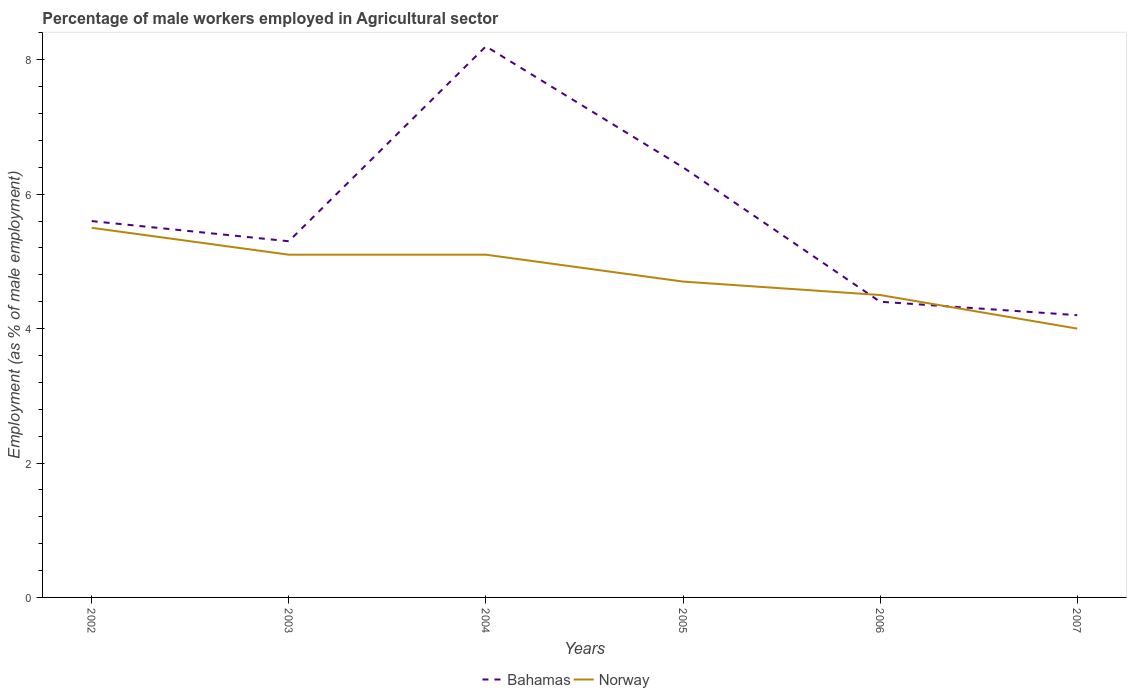How many different coloured lines are there?
Provide a succinct answer. 2. Is the number of lines equal to the number of legend labels?
Give a very brief answer. Yes. Across all years, what is the maximum percentage of male workers employed in Agricultural sector in Norway?
Offer a terse response. 4. What is the total percentage of male workers employed in Agricultural sector in Bahamas in the graph?
Give a very brief answer. -2.9. How many lines are there?
Offer a terse response. 2. How many legend labels are there?
Offer a terse response. 2. What is the title of the graph?
Give a very brief answer. Percentage of male workers employed in Agricultural sector. What is the label or title of the X-axis?
Offer a terse response. Years. What is the label or title of the Y-axis?
Your answer should be very brief. Employment (as % of male employment). What is the Employment (as % of male employment) of Bahamas in 2002?
Offer a very short reply. 5.6. What is the Employment (as % of male employment) of Norway in 2002?
Your answer should be compact. 5.5. What is the Employment (as % of male employment) in Bahamas in 2003?
Provide a succinct answer. 5.3. What is the Employment (as % of male employment) in Norway in 2003?
Keep it short and to the point. 5.1. What is the Employment (as % of male employment) in Bahamas in 2004?
Give a very brief answer. 8.2. What is the Employment (as % of male employment) in Norway in 2004?
Ensure brevity in your answer.  5.1. What is the Employment (as % of male employment) of Bahamas in 2005?
Keep it short and to the point. 6.4. What is the Employment (as % of male employment) of Norway in 2005?
Offer a very short reply. 4.7. What is the Employment (as % of male employment) of Bahamas in 2006?
Ensure brevity in your answer.  4.4. What is the Employment (as % of male employment) in Bahamas in 2007?
Your answer should be very brief. 4.2. What is the Employment (as % of male employment) of Norway in 2007?
Ensure brevity in your answer.  4. Across all years, what is the maximum Employment (as % of male employment) of Bahamas?
Give a very brief answer. 8.2. Across all years, what is the minimum Employment (as % of male employment) of Bahamas?
Your answer should be very brief. 4.2. Across all years, what is the minimum Employment (as % of male employment) of Norway?
Give a very brief answer. 4. What is the total Employment (as % of male employment) in Bahamas in the graph?
Your answer should be compact. 34.1. What is the total Employment (as % of male employment) in Norway in the graph?
Make the answer very short. 28.9. What is the difference between the Employment (as % of male employment) in Norway in 2002 and that in 2003?
Your answer should be compact. 0.4. What is the difference between the Employment (as % of male employment) of Bahamas in 2002 and that in 2005?
Provide a short and direct response. -0.8. What is the difference between the Employment (as % of male employment) of Norway in 2002 and that in 2006?
Your response must be concise. 1. What is the difference between the Employment (as % of male employment) of Bahamas in 2002 and that in 2007?
Make the answer very short. 1.4. What is the difference between the Employment (as % of male employment) in Norway in 2002 and that in 2007?
Provide a succinct answer. 1.5. What is the difference between the Employment (as % of male employment) in Bahamas in 2003 and that in 2004?
Offer a terse response. -2.9. What is the difference between the Employment (as % of male employment) of Norway in 2003 and that in 2004?
Your answer should be very brief. 0. What is the difference between the Employment (as % of male employment) of Norway in 2003 and that in 2006?
Provide a succinct answer. 0.6. What is the difference between the Employment (as % of male employment) in Bahamas in 2004 and that in 2006?
Keep it short and to the point. 3.8. What is the difference between the Employment (as % of male employment) in Norway in 2004 and that in 2006?
Provide a succinct answer. 0.6. What is the difference between the Employment (as % of male employment) in Bahamas in 2005 and that in 2006?
Keep it short and to the point. 2. What is the difference between the Employment (as % of male employment) in Bahamas in 2006 and that in 2007?
Provide a succinct answer. 0.2. What is the difference between the Employment (as % of male employment) in Norway in 2006 and that in 2007?
Keep it short and to the point. 0.5. What is the difference between the Employment (as % of male employment) in Bahamas in 2002 and the Employment (as % of male employment) in Norway in 2003?
Make the answer very short. 0.5. What is the difference between the Employment (as % of male employment) of Bahamas in 2002 and the Employment (as % of male employment) of Norway in 2004?
Keep it short and to the point. 0.5. What is the difference between the Employment (as % of male employment) of Bahamas in 2003 and the Employment (as % of male employment) of Norway in 2004?
Keep it short and to the point. 0.2. What is the average Employment (as % of male employment) of Bahamas per year?
Offer a very short reply. 5.68. What is the average Employment (as % of male employment) in Norway per year?
Keep it short and to the point. 4.82. In the year 2002, what is the difference between the Employment (as % of male employment) of Bahamas and Employment (as % of male employment) of Norway?
Give a very brief answer. 0.1. In the year 2007, what is the difference between the Employment (as % of male employment) of Bahamas and Employment (as % of male employment) of Norway?
Ensure brevity in your answer.  0.2. What is the ratio of the Employment (as % of male employment) in Bahamas in 2002 to that in 2003?
Offer a very short reply. 1.06. What is the ratio of the Employment (as % of male employment) of Norway in 2002 to that in 2003?
Give a very brief answer. 1.08. What is the ratio of the Employment (as % of male employment) in Bahamas in 2002 to that in 2004?
Your response must be concise. 0.68. What is the ratio of the Employment (as % of male employment) in Norway in 2002 to that in 2004?
Your response must be concise. 1.08. What is the ratio of the Employment (as % of male employment) in Norway in 2002 to that in 2005?
Give a very brief answer. 1.17. What is the ratio of the Employment (as % of male employment) in Bahamas in 2002 to that in 2006?
Provide a succinct answer. 1.27. What is the ratio of the Employment (as % of male employment) of Norway in 2002 to that in 2006?
Provide a succinct answer. 1.22. What is the ratio of the Employment (as % of male employment) in Norway in 2002 to that in 2007?
Make the answer very short. 1.38. What is the ratio of the Employment (as % of male employment) of Bahamas in 2003 to that in 2004?
Your response must be concise. 0.65. What is the ratio of the Employment (as % of male employment) in Bahamas in 2003 to that in 2005?
Your response must be concise. 0.83. What is the ratio of the Employment (as % of male employment) in Norway in 2003 to that in 2005?
Provide a succinct answer. 1.09. What is the ratio of the Employment (as % of male employment) in Bahamas in 2003 to that in 2006?
Keep it short and to the point. 1.2. What is the ratio of the Employment (as % of male employment) in Norway in 2003 to that in 2006?
Your response must be concise. 1.13. What is the ratio of the Employment (as % of male employment) in Bahamas in 2003 to that in 2007?
Your answer should be compact. 1.26. What is the ratio of the Employment (as % of male employment) in Norway in 2003 to that in 2007?
Make the answer very short. 1.27. What is the ratio of the Employment (as % of male employment) of Bahamas in 2004 to that in 2005?
Keep it short and to the point. 1.28. What is the ratio of the Employment (as % of male employment) of Norway in 2004 to that in 2005?
Offer a terse response. 1.09. What is the ratio of the Employment (as % of male employment) in Bahamas in 2004 to that in 2006?
Offer a terse response. 1.86. What is the ratio of the Employment (as % of male employment) of Norway in 2004 to that in 2006?
Give a very brief answer. 1.13. What is the ratio of the Employment (as % of male employment) in Bahamas in 2004 to that in 2007?
Your response must be concise. 1.95. What is the ratio of the Employment (as % of male employment) in Norway in 2004 to that in 2007?
Offer a very short reply. 1.27. What is the ratio of the Employment (as % of male employment) in Bahamas in 2005 to that in 2006?
Ensure brevity in your answer.  1.45. What is the ratio of the Employment (as % of male employment) of Norway in 2005 to that in 2006?
Your response must be concise. 1.04. What is the ratio of the Employment (as % of male employment) in Bahamas in 2005 to that in 2007?
Ensure brevity in your answer.  1.52. What is the ratio of the Employment (as % of male employment) in Norway in 2005 to that in 2007?
Make the answer very short. 1.18. What is the ratio of the Employment (as % of male employment) of Bahamas in 2006 to that in 2007?
Keep it short and to the point. 1.05. What is the ratio of the Employment (as % of male employment) of Norway in 2006 to that in 2007?
Your response must be concise. 1.12. What is the difference between the highest and the second highest Employment (as % of male employment) in Norway?
Give a very brief answer. 0.4. 